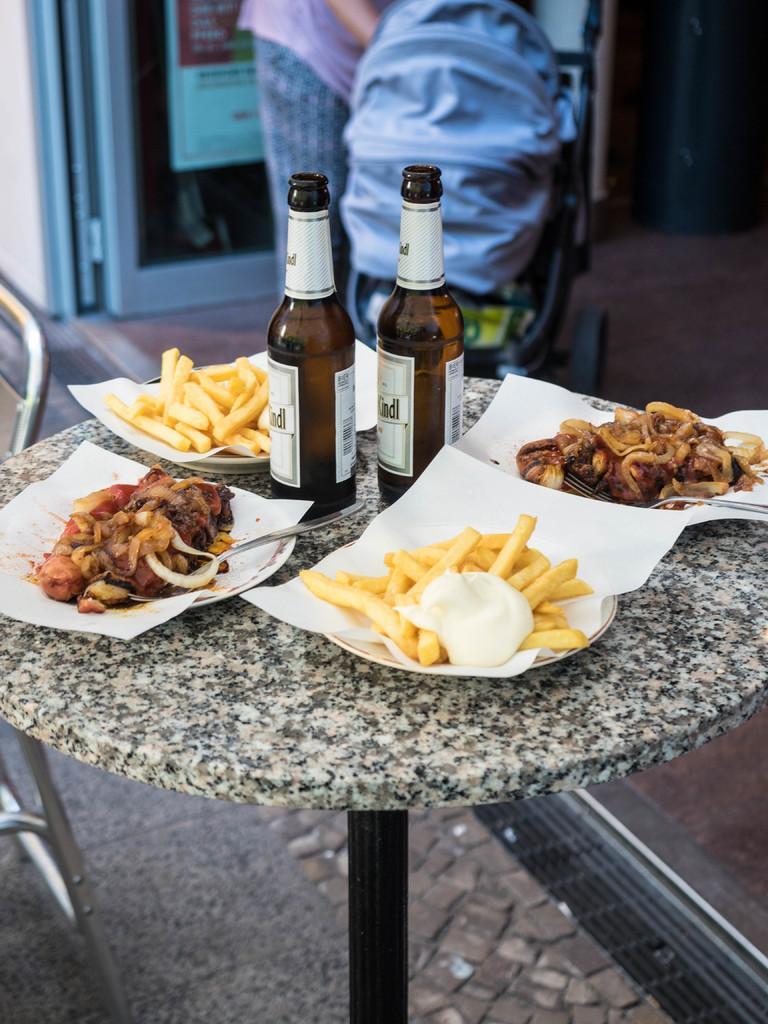Can you describe this image briefly? This is a table where two wine bottles and delicious food are kept on it. In the background we can see a bag kept on a chair. 